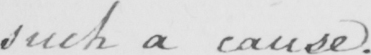Transcribe the text shown in this historical manuscript line. such a cause . 